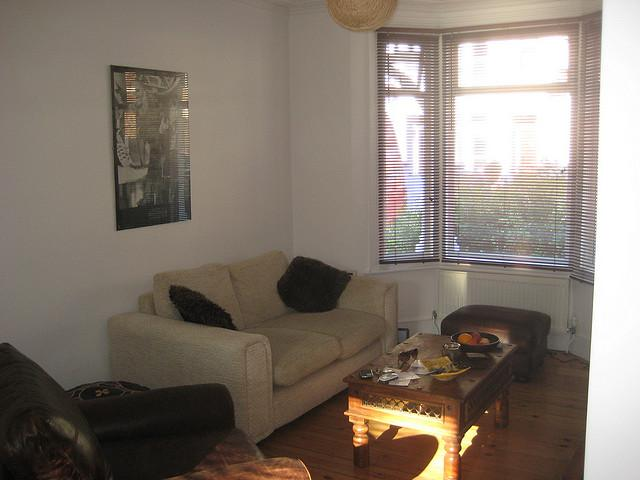What is on the wall? Please explain your reasoning. picture. The picture is on the wall. 